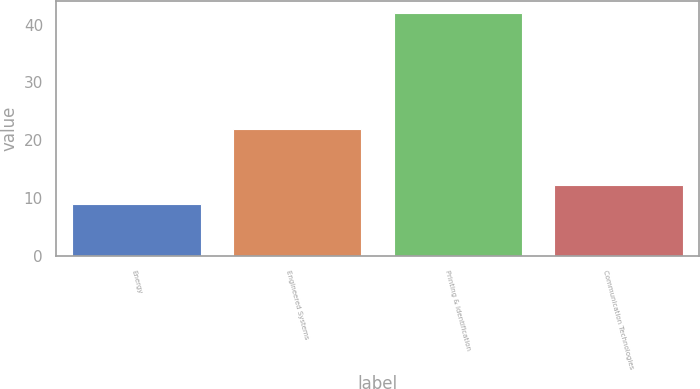Convert chart. <chart><loc_0><loc_0><loc_500><loc_500><bar_chart><fcel>Energy<fcel>Engineered Systems<fcel>Printing & Identification<fcel>Communication Technologies<nl><fcel>9<fcel>22<fcel>42<fcel>12.3<nl></chart> 